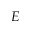<formula> <loc_0><loc_0><loc_500><loc_500>E</formula> 